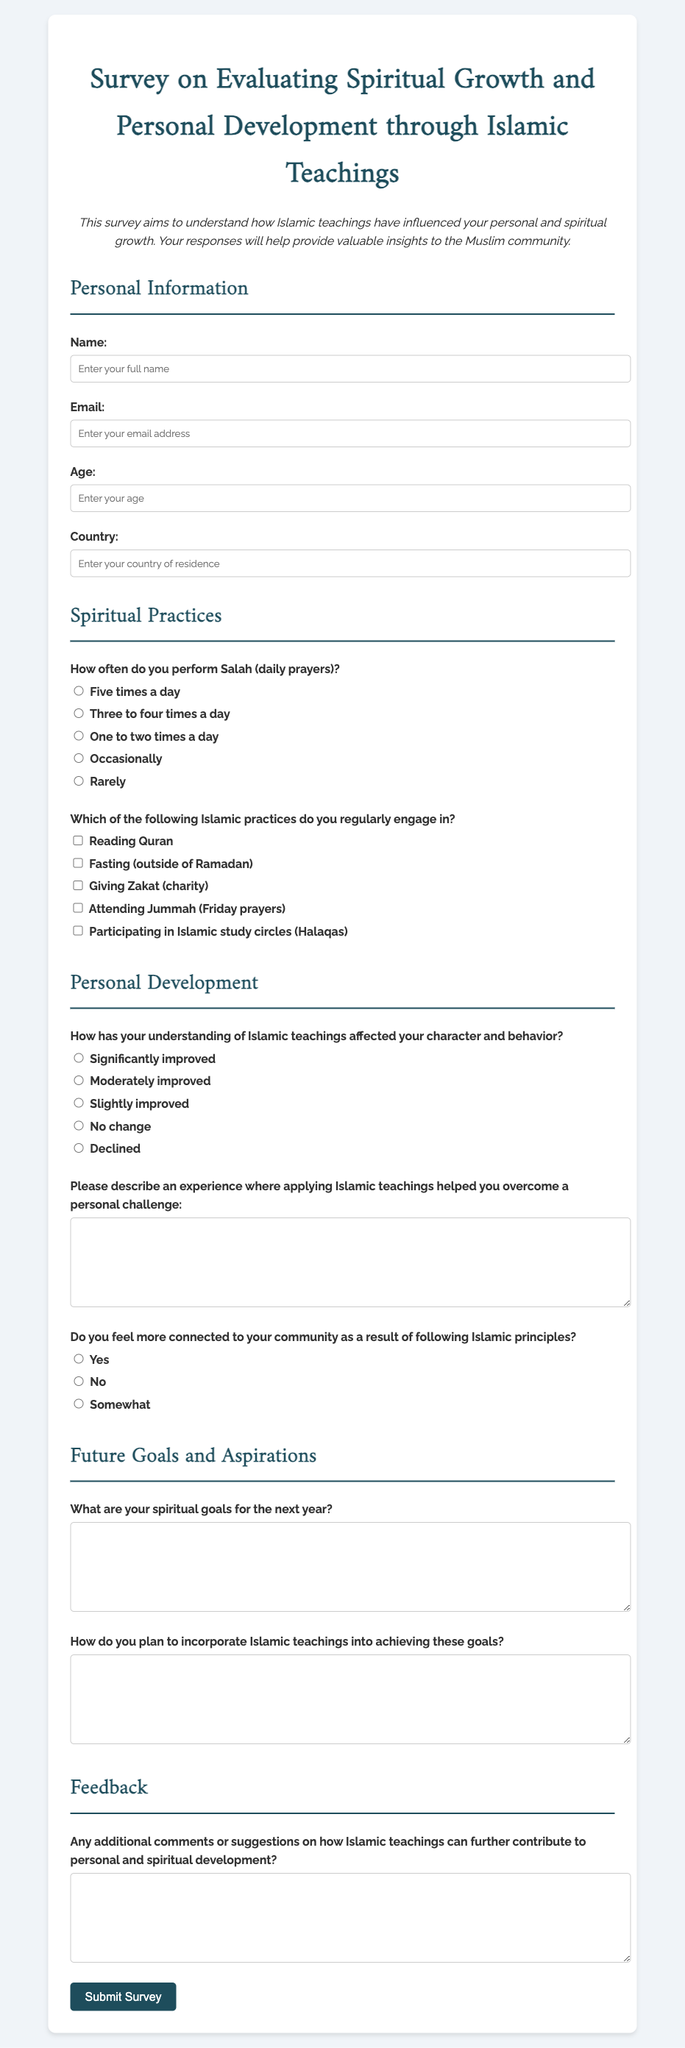What is the title of the survey? The title indicates the main focus of the survey which is on spiritual growth and personal development through Islamic teachings.
Answer: Survey on Evaluating Spiritual Growth and Personal Development through Islamic Teachings How many times a day do participants perform Salah? This question pertains to the frequency of Salah performance, a key aspect of Islamic practice detailed in the survey.
Answer: Five times a day What is one of the practices that participants can engage in according to the survey? This question refers to the list of Islamic practices mentioned in the survey, which participants can select from.
Answer: Reading Quran How many types of feedback sections are included in the survey? The question addresses the structural aspect of the survey, specifically the sections dedicated to feedback and suggestions.
Answer: One What demographic information is requested in the survey? This question pertains to the personal information section of the survey where demographic data is collected for better analysis.
Answer: Name, email, age, and country 